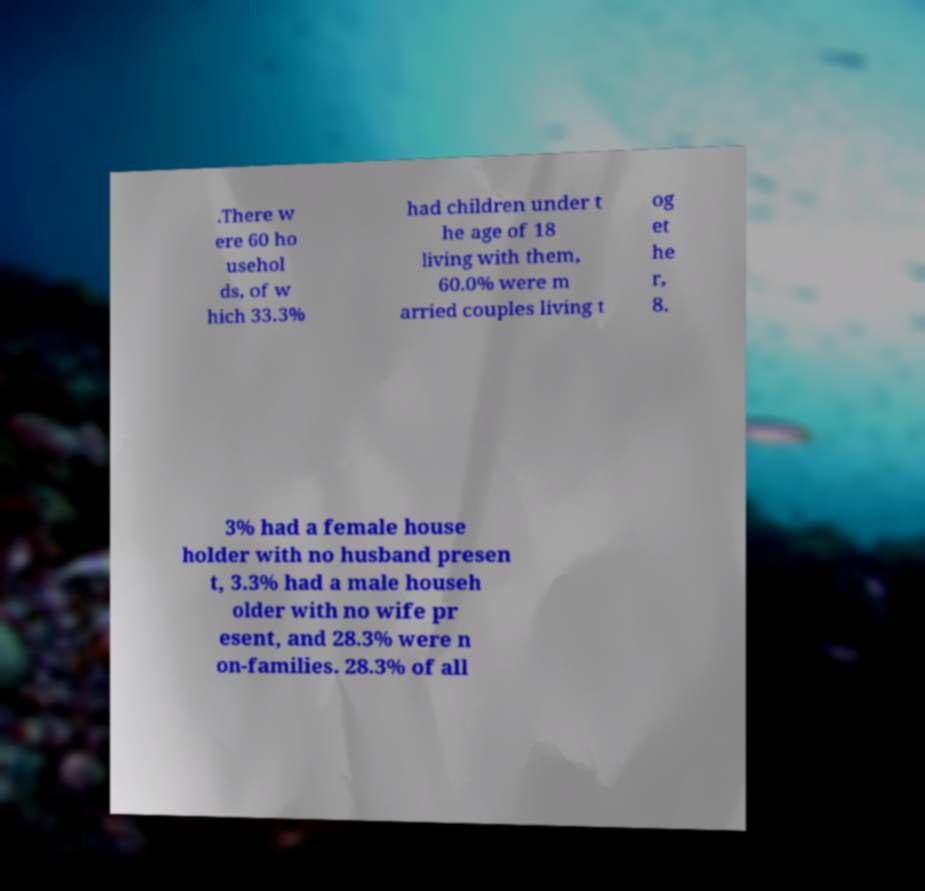Can you read and provide the text displayed in the image?This photo seems to have some interesting text. Can you extract and type it out for me? .There w ere 60 ho usehol ds, of w hich 33.3% had children under t he age of 18 living with them, 60.0% were m arried couples living t og et he r, 8. 3% had a female house holder with no husband presen t, 3.3% had a male househ older with no wife pr esent, and 28.3% were n on-families. 28.3% of all 